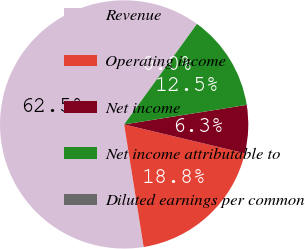Convert chart. <chart><loc_0><loc_0><loc_500><loc_500><pie_chart><fcel>Revenue<fcel>Operating income<fcel>Net income<fcel>Net income attributable to<fcel>Diluted earnings per common<nl><fcel>62.49%<fcel>18.75%<fcel>6.25%<fcel>12.5%<fcel>0.0%<nl></chart> 